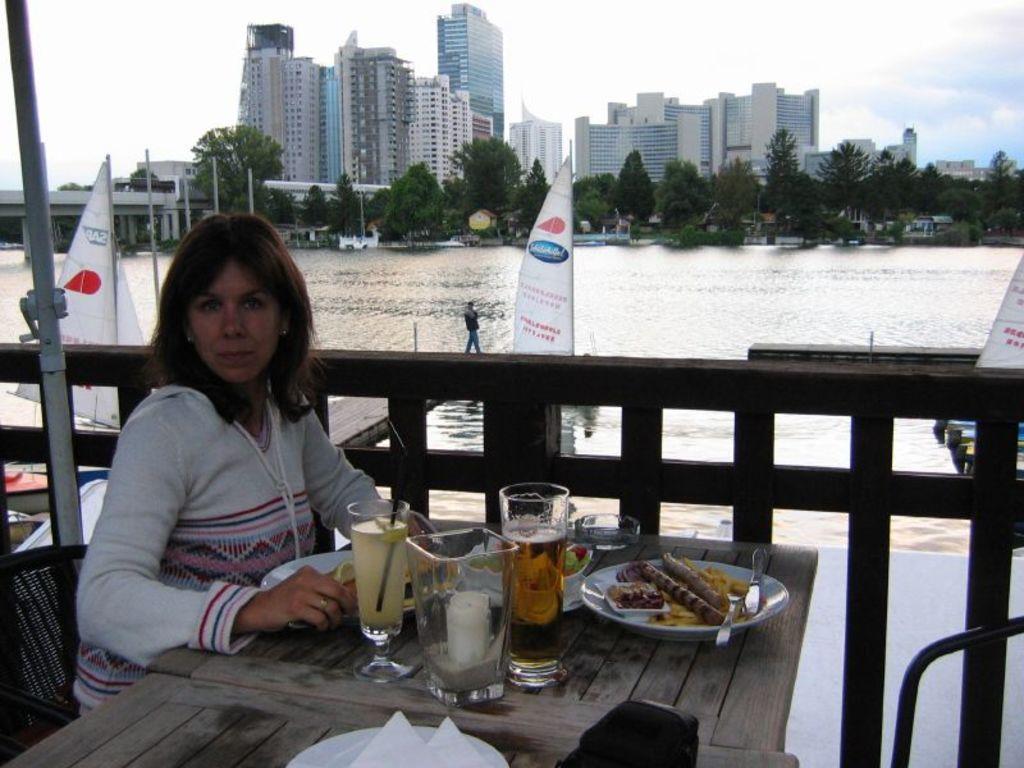Describe this image in one or two sentences. This picture is clicked outside. In the center there is a plateful of food, a glass of drink which is placed on the top of the table. On the left corner there is a metal rod. On the left there is a Woman sitting on the chair, behind her we can see the River in which there is a Sailboat. In the background the sky is full of clouds. There are some Trees, some Buildings and a Skyscraper. 